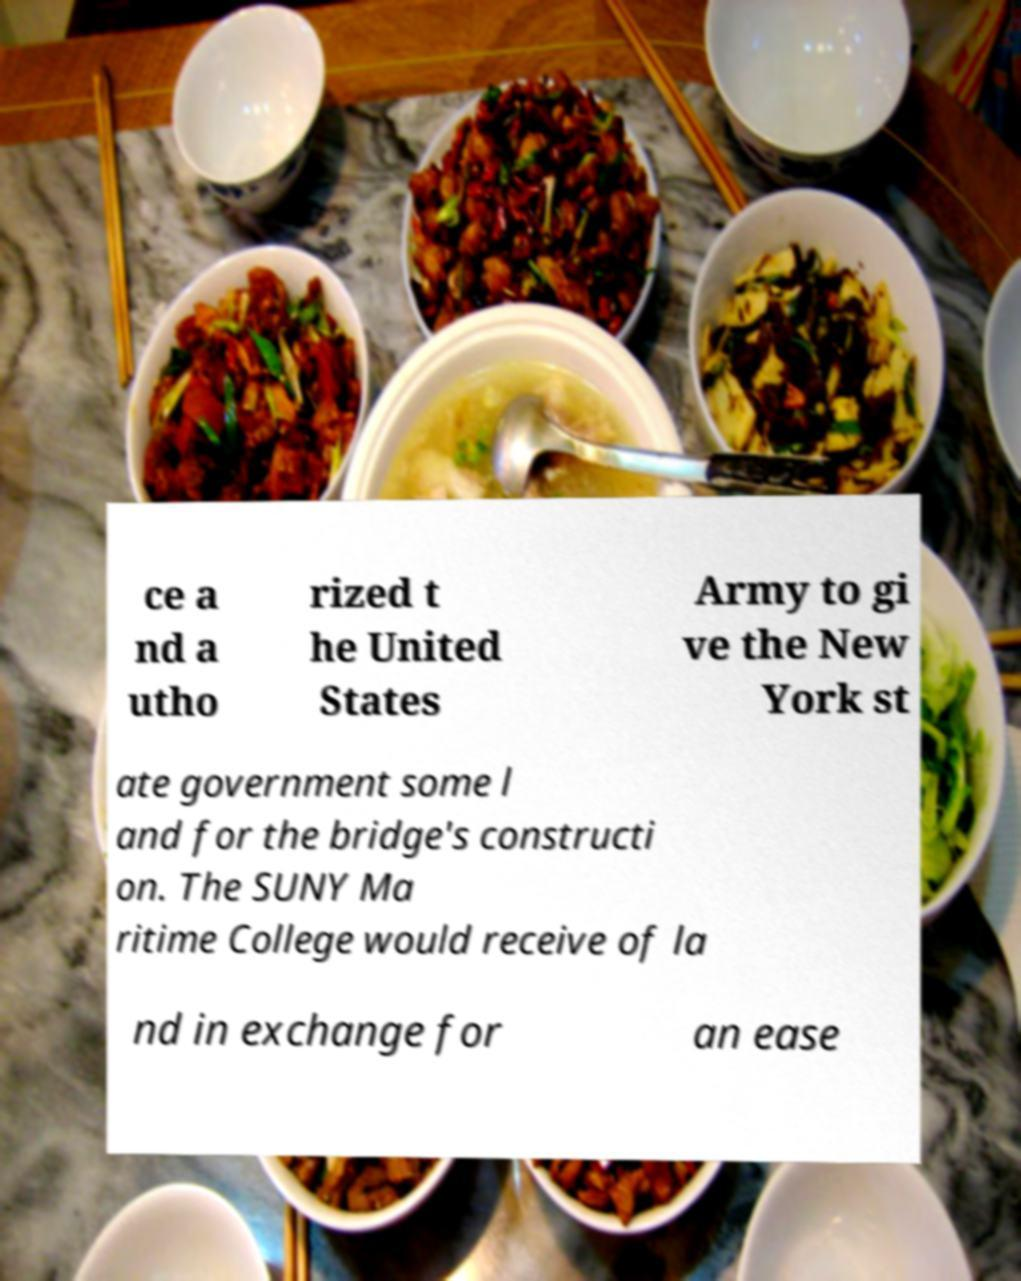Please read and relay the text visible in this image. What does it say? ce a nd a utho rized t he United States Army to gi ve the New York st ate government some l and for the bridge's constructi on. The SUNY Ma ritime College would receive of la nd in exchange for an ease 